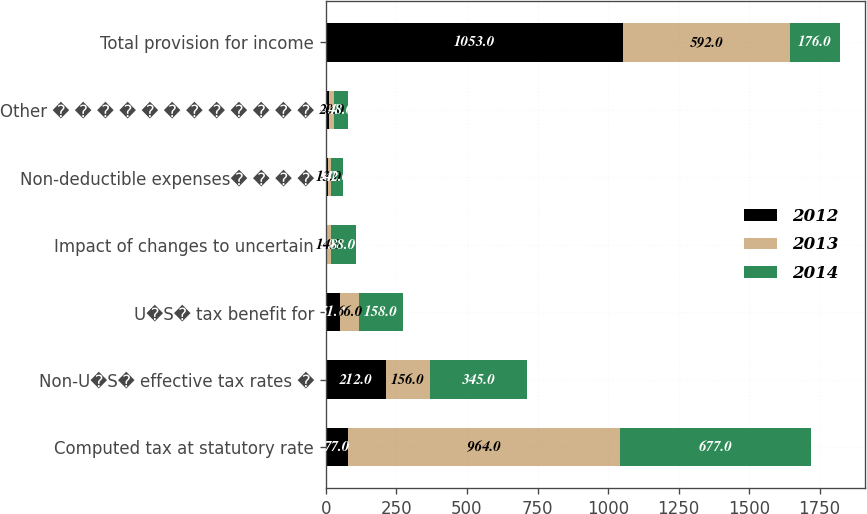Convert chart. <chart><loc_0><loc_0><loc_500><loc_500><stacked_bar_chart><ecel><fcel>Computed tax at statutory rate<fcel>Non-U�S� effective tax rates �<fcel>U�S� tax benefit for<fcel>Impact of changes to uncertain<fcel>Non-deductible expenses� � � �<fcel>Other � � � � � � � � � � � �<fcel>Total provision for income<nl><fcel>2012<fcel>77<fcel>212<fcel>51<fcel>3<fcel>6<fcel>10<fcel>1053<nl><fcel>2013<fcel>964<fcel>156<fcel>66<fcel>14<fcel>13<fcel>20<fcel>592<nl><fcel>2014<fcel>677<fcel>345<fcel>158<fcel>88<fcel>42<fcel>48<fcel>176<nl></chart> 